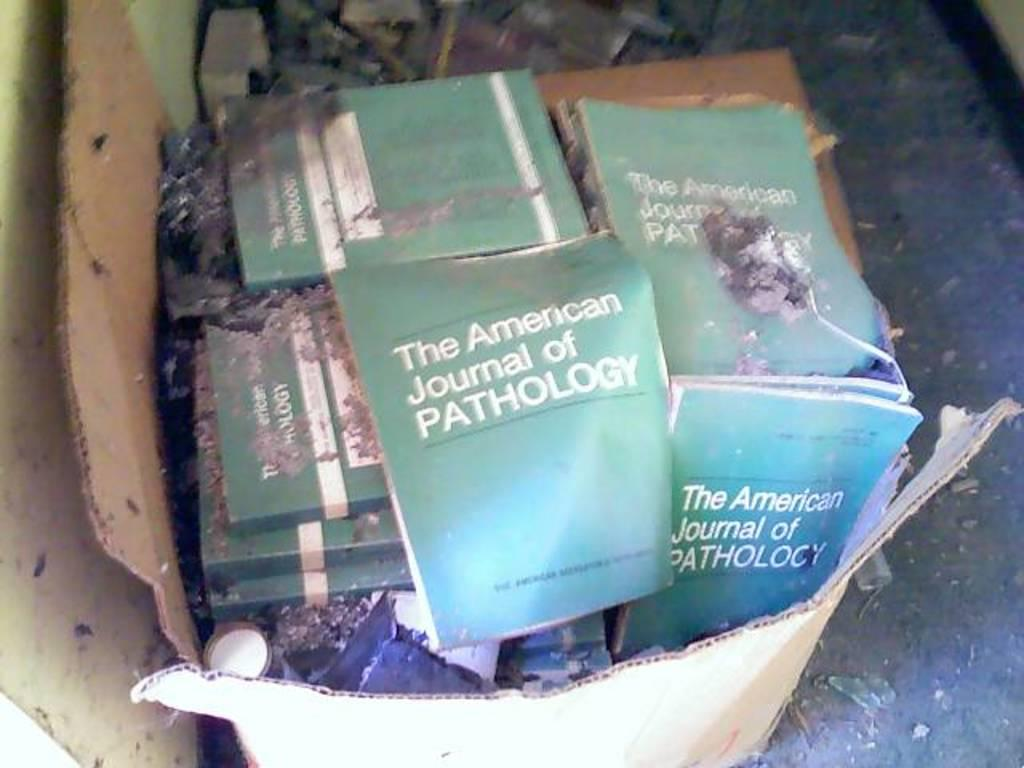<image>
Summarize the visual content of the image. A cardboard box has a bunch of The American Journal of Pathology books in it. 